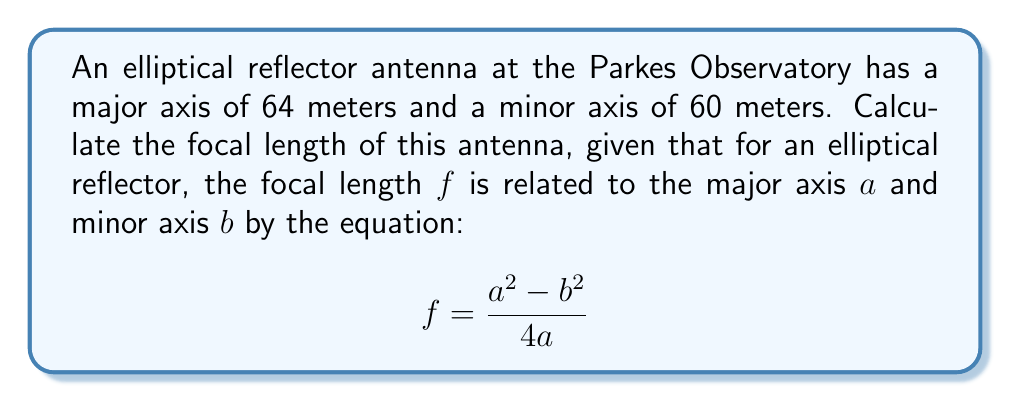Can you answer this question? To solve this problem, we'll follow these steps:

1. Identify the given values:
   - Major axis, $a = 64$ meters
   - Minor axis, $b = 60$ meters

2. Substitute these values into the focal length equation:

   $$ f = \frac{a^2 - b^2}{4a} $$

3. Calculate $a^2$ and $b^2$:
   $a^2 = 64^2 = 4096$
   $b^2 = 60^2 = 3600$

4. Substitute these values into the equation:

   $$ f = \frac{4096 - 3600}{4 \cdot 64} $$

5. Simplify the numerator:

   $$ f = \frac{496}{256} $$

6. Divide to get the final result:

   $$ f = 1.9375 $$

Therefore, the focal length of the elliptical reflector antenna is 1.9375 meters.

[asy]
import geometry;

size(200);

real a = 64;
real b = 60;
real f = 1.9375;

ellipse e = ellipse((0,0), a/2, b/2);
draw(e);

dot((-f,0), L="F");
dot((f,0), L="F'");
dot((0,0), L="C");

draw((-a/2,0)--(a/2,0), dashed);
draw((0,-b/2)--(0,b/2), dashed);

label("Major axis", (a/2,3), E);
label("Minor axis", (3,b/2), N);
[/asy]
Answer: 1.9375 meters 